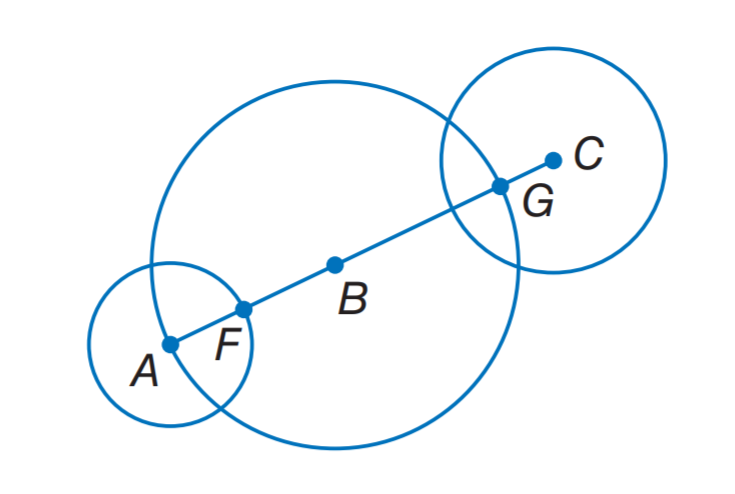Answer the mathemtical geometry problem and directly provide the correct option letter.
Question: The diameters of \odot A, \odot B, and \odot C are 8 inches, 18 inches, and 11 inches, respectively. Find F B.
Choices: A: 4 B: 5 C: 5.5 D: 11 B 